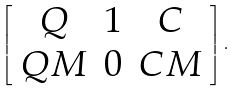<formula> <loc_0><loc_0><loc_500><loc_500>\left [ \begin{array} { c c c } Q & 1 & C \\ Q M & 0 & C M \end{array} \right ] .</formula> 